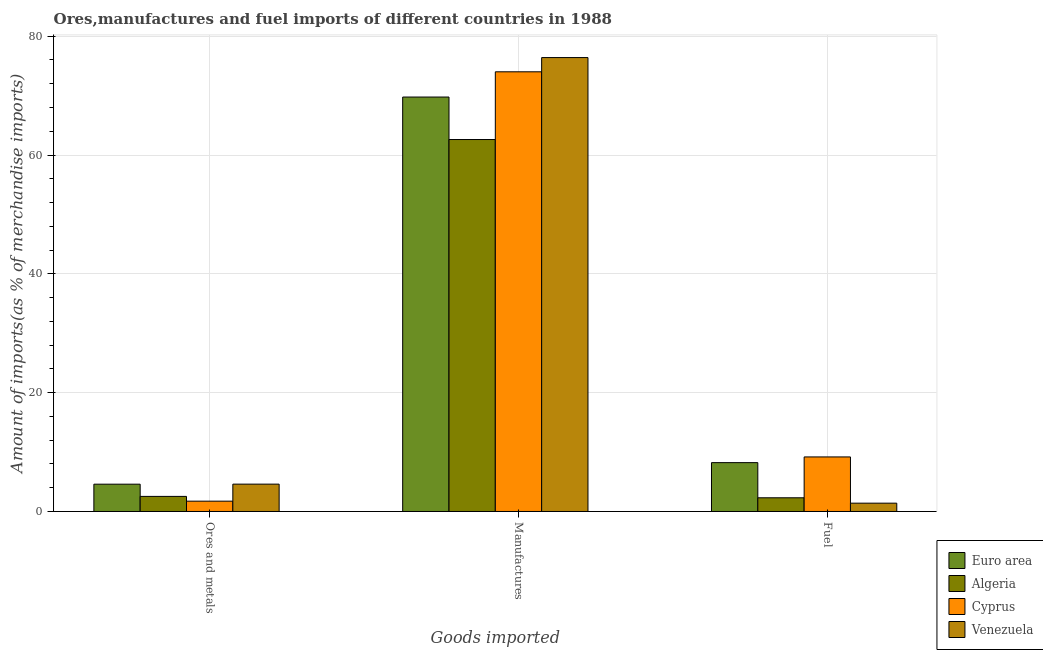How many groups of bars are there?
Your response must be concise. 3. Are the number of bars per tick equal to the number of legend labels?
Provide a short and direct response. Yes. How many bars are there on the 2nd tick from the right?
Your response must be concise. 4. What is the label of the 1st group of bars from the left?
Your answer should be compact. Ores and metals. What is the percentage of fuel imports in Algeria?
Provide a short and direct response. 2.31. Across all countries, what is the maximum percentage of manufactures imports?
Provide a short and direct response. 76.4. Across all countries, what is the minimum percentage of manufactures imports?
Offer a very short reply. 62.61. In which country was the percentage of manufactures imports maximum?
Give a very brief answer. Venezuela. In which country was the percentage of fuel imports minimum?
Ensure brevity in your answer.  Venezuela. What is the total percentage of manufactures imports in the graph?
Your answer should be very brief. 282.77. What is the difference between the percentage of manufactures imports in Cyprus and that in Algeria?
Ensure brevity in your answer.  11.4. What is the difference between the percentage of fuel imports in Venezuela and the percentage of ores and metals imports in Euro area?
Provide a short and direct response. -3.2. What is the average percentage of ores and metals imports per country?
Your response must be concise. 3.37. What is the difference between the percentage of fuel imports and percentage of manufactures imports in Venezuela?
Offer a terse response. -75. In how many countries, is the percentage of fuel imports greater than 64 %?
Keep it short and to the point. 0. What is the ratio of the percentage of ores and metals imports in Algeria to that in Euro area?
Make the answer very short. 0.55. Is the difference between the percentage of ores and metals imports in Cyprus and Euro area greater than the difference between the percentage of manufactures imports in Cyprus and Euro area?
Your answer should be compact. No. What is the difference between the highest and the second highest percentage of ores and metals imports?
Provide a succinct answer. 0.01. What is the difference between the highest and the lowest percentage of manufactures imports?
Give a very brief answer. 13.79. Is the sum of the percentage of manufactures imports in Venezuela and Euro area greater than the maximum percentage of fuel imports across all countries?
Give a very brief answer. Yes. What does the 4th bar from the left in Ores and metals represents?
Keep it short and to the point. Venezuela. What does the 2nd bar from the right in Ores and metals represents?
Offer a very short reply. Cyprus. How many bars are there?
Ensure brevity in your answer.  12. Are all the bars in the graph horizontal?
Your answer should be compact. No. How many countries are there in the graph?
Your answer should be very brief. 4. Are the values on the major ticks of Y-axis written in scientific E-notation?
Provide a short and direct response. No. Does the graph contain grids?
Provide a short and direct response. Yes. Where does the legend appear in the graph?
Your response must be concise. Bottom right. How are the legend labels stacked?
Provide a short and direct response. Vertical. What is the title of the graph?
Give a very brief answer. Ores,manufactures and fuel imports of different countries in 1988. What is the label or title of the X-axis?
Give a very brief answer. Goods imported. What is the label or title of the Y-axis?
Your response must be concise. Amount of imports(as % of merchandise imports). What is the Amount of imports(as % of merchandise imports) in Euro area in Ores and metals?
Your response must be concise. 4.6. What is the Amount of imports(as % of merchandise imports) of Algeria in Ores and metals?
Keep it short and to the point. 2.54. What is the Amount of imports(as % of merchandise imports) in Cyprus in Ores and metals?
Offer a terse response. 1.74. What is the Amount of imports(as % of merchandise imports) of Venezuela in Ores and metals?
Your response must be concise. 4.6. What is the Amount of imports(as % of merchandise imports) in Euro area in Manufactures?
Make the answer very short. 69.76. What is the Amount of imports(as % of merchandise imports) in Algeria in Manufactures?
Your answer should be very brief. 62.61. What is the Amount of imports(as % of merchandise imports) in Cyprus in Manufactures?
Provide a succinct answer. 74.01. What is the Amount of imports(as % of merchandise imports) of Venezuela in Manufactures?
Your response must be concise. 76.4. What is the Amount of imports(as % of merchandise imports) in Euro area in Fuel?
Make the answer very short. 8.22. What is the Amount of imports(as % of merchandise imports) in Algeria in Fuel?
Provide a short and direct response. 2.31. What is the Amount of imports(as % of merchandise imports) in Cyprus in Fuel?
Offer a very short reply. 9.18. What is the Amount of imports(as % of merchandise imports) in Venezuela in Fuel?
Your answer should be compact. 1.4. Across all Goods imported, what is the maximum Amount of imports(as % of merchandise imports) of Euro area?
Provide a short and direct response. 69.76. Across all Goods imported, what is the maximum Amount of imports(as % of merchandise imports) of Algeria?
Ensure brevity in your answer.  62.61. Across all Goods imported, what is the maximum Amount of imports(as % of merchandise imports) in Cyprus?
Offer a terse response. 74.01. Across all Goods imported, what is the maximum Amount of imports(as % of merchandise imports) of Venezuela?
Provide a succinct answer. 76.4. Across all Goods imported, what is the minimum Amount of imports(as % of merchandise imports) of Euro area?
Your answer should be compact. 4.6. Across all Goods imported, what is the minimum Amount of imports(as % of merchandise imports) in Algeria?
Ensure brevity in your answer.  2.31. Across all Goods imported, what is the minimum Amount of imports(as % of merchandise imports) of Cyprus?
Make the answer very short. 1.74. Across all Goods imported, what is the minimum Amount of imports(as % of merchandise imports) of Venezuela?
Provide a succinct answer. 1.4. What is the total Amount of imports(as % of merchandise imports) of Euro area in the graph?
Give a very brief answer. 82.58. What is the total Amount of imports(as % of merchandise imports) in Algeria in the graph?
Your answer should be very brief. 67.46. What is the total Amount of imports(as % of merchandise imports) of Cyprus in the graph?
Your response must be concise. 84.92. What is the total Amount of imports(as % of merchandise imports) in Venezuela in the graph?
Provide a succinct answer. 82.41. What is the difference between the Amount of imports(as % of merchandise imports) in Euro area in Ores and metals and that in Manufactures?
Keep it short and to the point. -65.16. What is the difference between the Amount of imports(as % of merchandise imports) in Algeria in Ores and metals and that in Manufactures?
Offer a very short reply. -60.07. What is the difference between the Amount of imports(as % of merchandise imports) of Cyprus in Ores and metals and that in Manufactures?
Your answer should be compact. -72.27. What is the difference between the Amount of imports(as % of merchandise imports) of Venezuela in Ores and metals and that in Manufactures?
Provide a succinct answer. -71.8. What is the difference between the Amount of imports(as % of merchandise imports) of Euro area in Ores and metals and that in Fuel?
Your response must be concise. -3.63. What is the difference between the Amount of imports(as % of merchandise imports) of Algeria in Ores and metals and that in Fuel?
Provide a succinct answer. 0.23. What is the difference between the Amount of imports(as % of merchandise imports) of Cyprus in Ores and metals and that in Fuel?
Give a very brief answer. -7.44. What is the difference between the Amount of imports(as % of merchandise imports) of Venezuela in Ores and metals and that in Fuel?
Provide a succinct answer. 3.2. What is the difference between the Amount of imports(as % of merchandise imports) of Euro area in Manufactures and that in Fuel?
Your answer should be very brief. 61.54. What is the difference between the Amount of imports(as % of merchandise imports) in Algeria in Manufactures and that in Fuel?
Keep it short and to the point. 60.3. What is the difference between the Amount of imports(as % of merchandise imports) in Cyprus in Manufactures and that in Fuel?
Give a very brief answer. 64.82. What is the difference between the Amount of imports(as % of merchandise imports) in Venezuela in Manufactures and that in Fuel?
Your answer should be very brief. 75. What is the difference between the Amount of imports(as % of merchandise imports) of Euro area in Ores and metals and the Amount of imports(as % of merchandise imports) of Algeria in Manufactures?
Make the answer very short. -58.01. What is the difference between the Amount of imports(as % of merchandise imports) of Euro area in Ores and metals and the Amount of imports(as % of merchandise imports) of Cyprus in Manufactures?
Your answer should be very brief. -69.41. What is the difference between the Amount of imports(as % of merchandise imports) in Euro area in Ores and metals and the Amount of imports(as % of merchandise imports) in Venezuela in Manufactures?
Provide a short and direct response. -71.81. What is the difference between the Amount of imports(as % of merchandise imports) in Algeria in Ores and metals and the Amount of imports(as % of merchandise imports) in Cyprus in Manufactures?
Ensure brevity in your answer.  -71.46. What is the difference between the Amount of imports(as % of merchandise imports) in Algeria in Ores and metals and the Amount of imports(as % of merchandise imports) in Venezuela in Manufactures?
Your answer should be compact. -73.86. What is the difference between the Amount of imports(as % of merchandise imports) of Cyprus in Ores and metals and the Amount of imports(as % of merchandise imports) of Venezuela in Manufactures?
Ensure brevity in your answer.  -74.66. What is the difference between the Amount of imports(as % of merchandise imports) of Euro area in Ores and metals and the Amount of imports(as % of merchandise imports) of Algeria in Fuel?
Ensure brevity in your answer.  2.29. What is the difference between the Amount of imports(as % of merchandise imports) in Euro area in Ores and metals and the Amount of imports(as % of merchandise imports) in Cyprus in Fuel?
Provide a short and direct response. -4.59. What is the difference between the Amount of imports(as % of merchandise imports) of Euro area in Ores and metals and the Amount of imports(as % of merchandise imports) of Venezuela in Fuel?
Ensure brevity in your answer.  3.2. What is the difference between the Amount of imports(as % of merchandise imports) of Algeria in Ores and metals and the Amount of imports(as % of merchandise imports) of Cyprus in Fuel?
Make the answer very short. -6.64. What is the difference between the Amount of imports(as % of merchandise imports) in Algeria in Ores and metals and the Amount of imports(as % of merchandise imports) in Venezuela in Fuel?
Offer a terse response. 1.14. What is the difference between the Amount of imports(as % of merchandise imports) of Cyprus in Ores and metals and the Amount of imports(as % of merchandise imports) of Venezuela in Fuel?
Give a very brief answer. 0.34. What is the difference between the Amount of imports(as % of merchandise imports) in Euro area in Manufactures and the Amount of imports(as % of merchandise imports) in Algeria in Fuel?
Ensure brevity in your answer.  67.45. What is the difference between the Amount of imports(as % of merchandise imports) in Euro area in Manufactures and the Amount of imports(as % of merchandise imports) in Cyprus in Fuel?
Make the answer very short. 60.58. What is the difference between the Amount of imports(as % of merchandise imports) in Euro area in Manufactures and the Amount of imports(as % of merchandise imports) in Venezuela in Fuel?
Your answer should be compact. 68.36. What is the difference between the Amount of imports(as % of merchandise imports) in Algeria in Manufactures and the Amount of imports(as % of merchandise imports) in Cyprus in Fuel?
Give a very brief answer. 53.43. What is the difference between the Amount of imports(as % of merchandise imports) of Algeria in Manufactures and the Amount of imports(as % of merchandise imports) of Venezuela in Fuel?
Ensure brevity in your answer.  61.21. What is the difference between the Amount of imports(as % of merchandise imports) in Cyprus in Manufactures and the Amount of imports(as % of merchandise imports) in Venezuela in Fuel?
Your answer should be compact. 72.6. What is the average Amount of imports(as % of merchandise imports) in Euro area per Goods imported?
Your answer should be compact. 27.53. What is the average Amount of imports(as % of merchandise imports) of Algeria per Goods imported?
Your response must be concise. 22.48. What is the average Amount of imports(as % of merchandise imports) in Cyprus per Goods imported?
Offer a terse response. 28.31. What is the average Amount of imports(as % of merchandise imports) of Venezuela per Goods imported?
Your response must be concise. 27.47. What is the difference between the Amount of imports(as % of merchandise imports) in Euro area and Amount of imports(as % of merchandise imports) in Algeria in Ores and metals?
Offer a very short reply. 2.06. What is the difference between the Amount of imports(as % of merchandise imports) in Euro area and Amount of imports(as % of merchandise imports) in Cyprus in Ores and metals?
Your answer should be very brief. 2.86. What is the difference between the Amount of imports(as % of merchandise imports) of Euro area and Amount of imports(as % of merchandise imports) of Venezuela in Ores and metals?
Offer a terse response. -0.01. What is the difference between the Amount of imports(as % of merchandise imports) in Algeria and Amount of imports(as % of merchandise imports) in Cyprus in Ores and metals?
Your answer should be compact. 0.8. What is the difference between the Amount of imports(as % of merchandise imports) of Algeria and Amount of imports(as % of merchandise imports) of Venezuela in Ores and metals?
Give a very brief answer. -2.06. What is the difference between the Amount of imports(as % of merchandise imports) in Cyprus and Amount of imports(as % of merchandise imports) in Venezuela in Ores and metals?
Make the answer very short. -2.87. What is the difference between the Amount of imports(as % of merchandise imports) of Euro area and Amount of imports(as % of merchandise imports) of Algeria in Manufactures?
Provide a short and direct response. 7.15. What is the difference between the Amount of imports(as % of merchandise imports) in Euro area and Amount of imports(as % of merchandise imports) in Cyprus in Manufactures?
Keep it short and to the point. -4.25. What is the difference between the Amount of imports(as % of merchandise imports) in Euro area and Amount of imports(as % of merchandise imports) in Venezuela in Manufactures?
Offer a terse response. -6.64. What is the difference between the Amount of imports(as % of merchandise imports) in Algeria and Amount of imports(as % of merchandise imports) in Cyprus in Manufactures?
Ensure brevity in your answer.  -11.4. What is the difference between the Amount of imports(as % of merchandise imports) of Algeria and Amount of imports(as % of merchandise imports) of Venezuela in Manufactures?
Provide a short and direct response. -13.79. What is the difference between the Amount of imports(as % of merchandise imports) in Cyprus and Amount of imports(as % of merchandise imports) in Venezuela in Manufactures?
Offer a very short reply. -2.4. What is the difference between the Amount of imports(as % of merchandise imports) in Euro area and Amount of imports(as % of merchandise imports) in Algeria in Fuel?
Make the answer very short. 5.92. What is the difference between the Amount of imports(as % of merchandise imports) of Euro area and Amount of imports(as % of merchandise imports) of Cyprus in Fuel?
Keep it short and to the point. -0.96. What is the difference between the Amount of imports(as % of merchandise imports) in Euro area and Amount of imports(as % of merchandise imports) in Venezuela in Fuel?
Make the answer very short. 6.82. What is the difference between the Amount of imports(as % of merchandise imports) in Algeria and Amount of imports(as % of merchandise imports) in Cyprus in Fuel?
Your answer should be compact. -6.88. What is the difference between the Amount of imports(as % of merchandise imports) in Algeria and Amount of imports(as % of merchandise imports) in Venezuela in Fuel?
Keep it short and to the point. 0.91. What is the difference between the Amount of imports(as % of merchandise imports) of Cyprus and Amount of imports(as % of merchandise imports) of Venezuela in Fuel?
Provide a succinct answer. 7.78. What is the ratio of the Amount of imports(as % of merchandise imports) in Euro area in Ores and metals to that in Manufactures?
Your response must be concise. 0.07. What is the ratio of the Amount of imports(as % of merchandise imports) in Algeria in Ores and metals to that in Manufactures?
Offer a very short reply. 0.04. What is the ratio of the Amount of imports(as % of merchandise imports) in Cyprus in Ores and metals to that in Manufactures?
Ensure brevity in your answer.  0.02. What is the ratio of the Amount of imports(as % of merchandise imports) in Venezuela in Ores and metals to that in Manufactures?
Provide a succinct answer. 0.06. What is the ratio of the Amount of imports(as % of merchandise imports) in Euro area in Ores and metals to that in Fuel?
Offer a terse response. 0.56. What is the ratio of the Amount of imports(as % of merchandise imports) of Algeria in Ores and metals to that in Fuel?
Give a very brief answer. 1.1. What is the ratio of the Amount of imports(as % of merchandise imports) of Cyprus in Ores and metals to that in Fuel?
Provide a short and direct response. 0.19. What is the ratio of the Amount of imports(as % of merchandise imports) of Venezuela in Ores and metals to that in Fuel?
Your answer should be very brief. 3.29. What is the ratio of the Amount of imports(as % of merchandise imports) in Euro area in Manufactures to that in Fuel?
Provide a succinct answer. 8.48. What is the ratio of the Amount of imports(as % of merchandise imports) in Algeria in Manufactures to that in Fuel?
Ensure brevity in your answer.  27.15. What is the ratio of the Amount of imports(as % of merchandise imports) in Cyprus in Manufactures to that in Fuel?
Your answer should be compact. 8.06. What is the ratio of the Amount of imports(as % of merchandise imports) in Venezuela in Manufactures to that in Fuel?
Provide a short and direct response. 54.56. What is the difference between the highest and the second highest Amount of imports(as % of merchandise imports) of Euro area?
Offer a very short reply. 61.54. What is the difference between the highest and the second highest Amount of imports(as % of merchandise imports) of Algeria?
Provide a succinct answer. 60.07. What is the difference between the highest and the second highest Amount of imports(as % of merchandise imports) in Cyprus?
Keep it short and to the point. 64.82. What is the difference between the highest and the second highest Amount of imports(as % of merchandise imports) of Venezuela?
Provide a short and direct response. 71.8. What is the difference between the highest and the lowest Amount of imports(as % of merchandise imports) of Euro area?
Provide a succinct answer. 65.16. What is the difference between the highest and the lowest Amount of imports(as % of merchandise imports) in Algeria?
Make the answer very short. 60.3. What is the difference between the highest and the lowest Amount of imports(as % of merchandise imports) in Cyprus?
Your response must be concise. 72.27. What is the difference between the highest and the lowest Amount of imports(as % of merchandise imports) of Venezuela?
Your response must be concise. 75. 